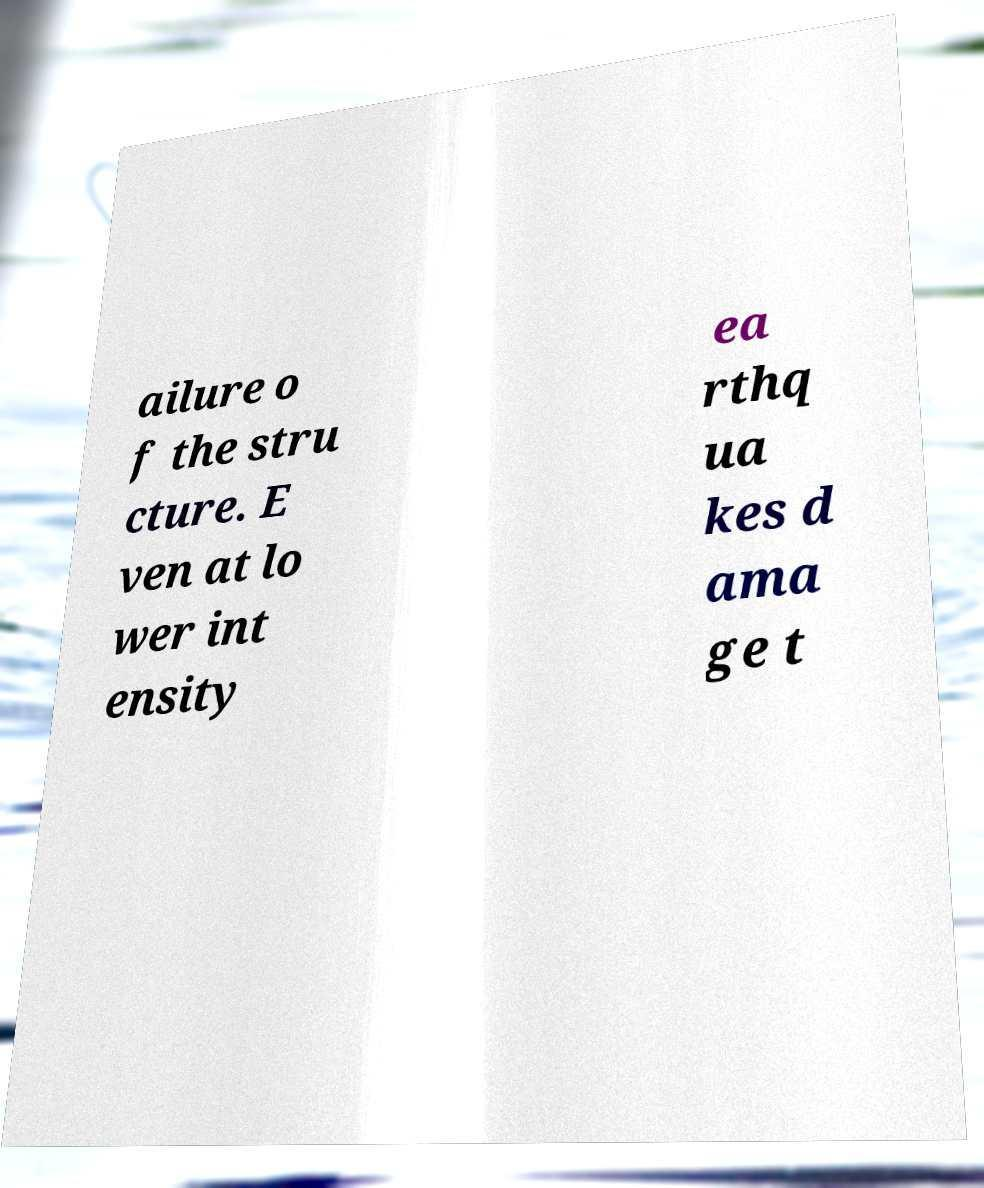Could you assist in decoding the text presented in this image and type it out clearly? ailure o f the stru cture. E ven at lo wer int ensity ea rthq ua kes d ama ge t 